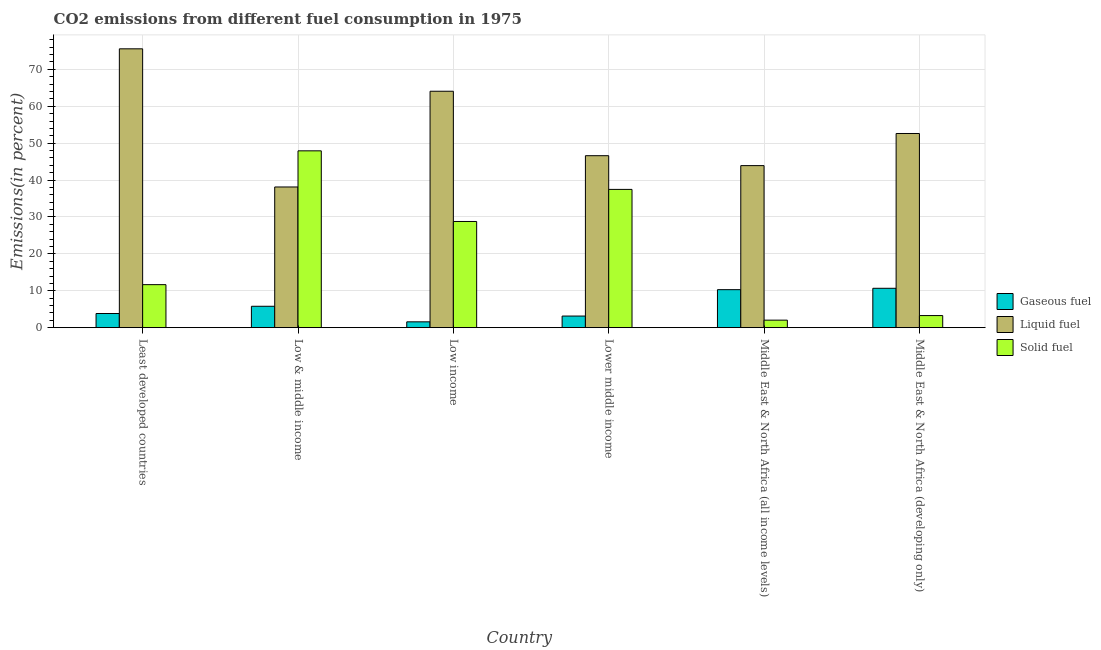How many different coloured bars are there?
Your answer should be compact. 3. Are the number of bars per tick equal to the number of legend labels?
Offer a very short reply. Yes. Are the number of bars on each tick of the X-axis equal?
Your answer should be compact. Yes. How many bars are there on the 2nd tick from the right?
Offer a very short reply. 3. What is the label of the 1st group of bars from the left?
Provide a short and direct response. Least developed countries. What is the percentage of gaseous fuel emission in Middle East & North Africa (developing only)?
Give a very brief answer. 10.67. Across all countries, what is the maximum percentage of liquid fuel emission?
Offer a very short reply. 75.57. Across all countries, what is the minimum percentage of gaseous fuel emission?
Provide a succinct answer. 1.58. In which country was the percentage of liquid fuel emission maximum?
Your answer should be very brief. Least developed countries. What is the total percentage of solid fuel emission in the graph?
Your answer should be compact. 131.15. What is the difference between the percentage of liquid fuel emission in Low income and that in Middle East & North Africa (developing only)?
Provide a succinct answer. 11.45. What is the difference between the percentage of liquid fuel emission in Low & middle income and the percentage of solid fuel emission in Least developed countries?
Keep it short and to the point. 26.47. What is the average percentage of liquid fuel emission per country?
Make the answer very short. 53.49. What is the difference between the percentage of solid fuel emission and percentage of gaseous fuel emission in Middle East & North Africa (all income levels)?
Your response must be concise. -8.26. What is the ratio of the percentage of gaseous fuel emission in Least developed countries to that in Lower middle income?
Your answer should be very brief. 1.22. What is the difference between the highest and the second highest percentage of gaseous fuel emission?
Offer a terse response. 0.37. What is the difference between the highest and the lowest percentage of solid fuel emission?
Keep it short and to the point. 45.89. Is the sum of the percentage of gaseous fuel emission in Low income and Middle East & North Africa (all income levels) greater than the maximum percentage of solid fuel emission across all countries?
Your answer should be very brief. No. What does the 2nd bar from the left in Low & middle income represents?
Ensure brevity in your answer.  Liquid fuel. What does the 3rd bar from the right in Low income represents?
Make the answer very short. Gaseous fuel. Is it the case that in every country, the sum of the percentage of gaseous fuel emission and percentage of liquid fuel emission is greater than the percentage of solid fuel emission?
Offer a terse response. No. Are all the bars in the graph horizontal?
Provide a succinct answer. No. How many countries are there in the graph?
Provide a succinct answer. 6. Are the values on the major ticks of Y-axis written in scientific E-notation?
Make the answer very short. No. Does the graph contain any zero values?
Your answer should be compact. No. Does the graph contain grids?
Give a very brief answer. Yes. How many legend labels are there?
Give a very brief answer. 3. How are the legend labels stacked?
Offer a very short reply. Vertical. What is the title of the graph?
Offer a terse response. CO2 emissions from different fuel consumption in 1975. Does "Slovak Republic" appear as one of the legend labels in the graph?
Make the answer very short. No. What is the label or title of the Y-axis?
Your answer should be compact. Emissions(in percent). What is the Emissions(in percent) in Gaseous fuel in Least developed countries?
Provide a short and direct response. 3.84. What is the Emissions(in percent) in Liquid fuel in Least developed countries?
Give a very brief answer. 75.57. What is the Emissions(in percent) of Solid fuel in Least developed countries?
Offer a terse response. 11.66. What is the Emissions(in percent) in Gaseous fuel in Low & middle income?
Provide a short and direct response. 5.8. What is the Emissions(in percent) of Liquid fuel in Low & middle income?
Give a very brief answer. 38.13. What is the Emissions(in percent) in Solid fuel in Low & middle income?
Give a very brief answer. 47.92. What is the Emissions(in percent) in Gaseous fuel in Low income?
Offer a terse response. 1.58. What is the Emissions(in percent) in Liquid fuel in Low income?
Your response must be concise. 64.07. What is the Emissions(in percent) of Solid fuel in Low income?
Offer a very short reply. 28.78. What is the Emissions(in percent) of Gaseous fuel in Lower middle income?
Give a very brief answer. 3.15. What is the Emissions(in percent) in Liquid fuel in Lower middle income?
Offer a very short reply. 46.61. What is the Emissions(in percent) in Solid fuel in Lower middle income?
Provide a short and direct response. 37.47. What is the Emissions(in percent) in Gaseous fuel in Middle East & North Africa (all income levels)?
Offer a terse response. 10.3. What is the Emissions(in percent) of Liquid fuel in Middle East & North Africa (all income levels)?
Your response must be concise. 43.92. What is the Emissions(in percent) of Solid fuel in Middle East & North Africa (all income levels)?
Give a very brief answer. 2.04. What is the Emissions(in percent) of Gaseous fuel in Middle East & North Africa (developing only)?
Your answer should be very brief. 10.67. What is the Emissions(in percent) in Liquid fuel in Middle East & North Africa (developing only)?
Make the answer very short. 52.63. What is the Emissions(in percent) of Solid fuel in Middle East & North Africa (developing only)?
Your answer should be very brief. 3.28. Across all countries, what is the maximum Emissions(in percent) of Gaseous fuel?
Make the answer very short. 10.67. Across all countries, what is the maximum Emissions(in percent) of Liquid fuel?
Ensure brevity in your answer.  75.57. Across all countries, what is the maximum Emissions(in percent) of Solid fuel?
Make the answer very short. 47.92. Across all countries, what is the minimum Emissions(in percent) of Gaseous fuel?
Keep it short and to the point. 1.58. Across all countries, what is the minimum Emissions(in percent) of Liquid fuel?
Ensure brevity in your answer.  38.13. Across all countries, what is the minimum Emissions(in percent) in Solid fuel?
Your answer should be compact. 2.04. What is the total Emissions(in percent) in Gaseous fuel in the graph?
Offer a terse response. 35.33. What is the total Emissions(in percent) in Liquid fuel in the graph?
Provide a short and direct response. 320.93. What is the total Emissions(in percent) in Solid fuel in the graph?
Offer a very short reply. 131.15. What is the difference between the Emissions(in percent) in Gaseous fuel in Least developed countries and that in Low & middle income?
Offer a terse response. -1.96. What is the difference between the Emissions(in percent) of Liquid fuel in Least developed countries and that in Low & middle income?
Your response must be concise. 37.44. What is the difference between the Emissions(in percent) in Solid fuel in Least developed countries and that in Low & middle income?
Your response must be concise. -36.27. What is the difference between the Emissions(in percent) in Gaseous fuel in Least developed countries and that in Low income?
Provide a succinct answer. 2.26. What is the difference between the Emissions(in percent) of Liquid fuel in Least developed countries and that in Low income?
Offer a very short reply. 11.5. What is the difference between the Emissions(in percent) in Solid fuel in Least developed countries and that in Low income?
Your answer should be compact. -17.12. What is the difference between the Emissions(in percent) of Gaseous fuel in Least developed countries and that in Lower middle income?
Your response must be concise. 0.69. What is the difference between the Emissions(in percent) in Liquid fuel in Least developed countries and that in Lower middle income?
Provide a succinct answer. 28.97. What is the difference between the Emissions(in percent) in Solid fuel in Least developed countries and that in Lower middle income?
Offer a terse response. -25.82. What is the difference between the Emissions(in percent) in Gaseous fuel in Least developed countries and that in Middle East & North Africa (all income levels)?
Your response must be concise. -6.46. What is the difference between the Emissions(in percent) of Liquid fuel in Least developed countries and that in Middle East & North Africa (all income levels)?
Provide a succinct answer. 31.65. What is the difference between the Emissions(in percent) in Solid fuel in Least developed countries and that in Middle East & North Africa (all income levels)?
Your answer should be very brief. 9.62. What is the difference between the Emissions(in percent) of Gaseous fuel in Least developed countries and that in Middle East & North Africa (developing only)?
Provide a short and direct response. -6.83. What is the difference between the Emissions(in percent) of Liquid fuel in Least developed countries and that in Middle East & North Africa (developing only)?
Offer a very short reply. 22.95. What is the difference between the Emissions(in percent) in Solid fuel in Least developed countries and that in Middle East & North Africa (developing only)?
Provide a succinct answer. 8.38. What is the difference between the Emissions(in percent) in Gaseous fuel in Low & middle income and that in Low income?
Your answer should be compact. 4.22. What is the difference between the Emissions(in percent) in Liquid fuel in Low & middle income and that in Low income?
Offer a terse response. -25.94. What is the difference between the Emissions(in percent) in Solid fuel in Low & middle income and that in Low income?
Offer a terse response. 19.14. What is the difference between the Emissions(in percent) in Gaseous fuel in Low & middle income and that in Lower middle income?
Your answer should be compact. 2.65. What is the difference between the Emissions(in percent) of Liquid fuel in Low & middle income and that in Lower middle income?
Ensure brevity in your answer.  -8.48. What is the difference between the Emissions(in percent) of Solid fuel in Low & middle income and that in Lower middle income?
Your response must be concise. 10.45. What is the difference between the Emissions(in percent) of Gaseous fuel in Low & middle income and that in Middle East & North Africa (all income levels)?
Your answer should be compact. -4.5. What is the difference between the Emissions(in percent) in Liquid fuel in Low & middle income and that in Middle East & North Africa (all income levels)?
Ensure brevity in your answer.  -5.79. What is the difference between the Emissions(in percent) of Solid fuel in Low & middle income and that in Middle East & North Africa (all income levels)?
Offer a terse response. 45.89. What is the difference between the Emissions(in percent) in Gaseous fuel in Low & middle income and that in Middle East & North Africa (developing only)?
Give a very brief answer. -4.88. What is the difference between the Emissions(in percent) of Liquid fuel in Low & middle income and that in Middle East & North Africa (developing only)?
Your answer should be very brief. -14.5. What is the difference between the Emissions(in percent) in Solid fuel in Low & middle income and that in Middle East & North Africa (developing only)?
Your answer should be compact. 44.65. What is the difference between the Emissions(in percent) in Gaseous fuel in Low income and that in Lower middle income?
Make the answer very short. -1.57. What is the difference between the Emissions(in percent) of Liquid fuel in Low income and that in Lower middle income?
Offer a terse response. 17.47. What is the difference between the Emissions(in percent) of Solid fuel in Low income and that in Lower middle income?
Make the answer very short. -8.69. What is the difference between the Emissions(in percent) in Gaseous fuel in Low income and that in Middle East & North Africa (all income levels)?
Ensure brevity in your answer.  -8.72. What is the difference between the Emissions(in percent) of Liquid fuel in Low income and that in Middle East & North Africa (all income levels)?
Keep it short and to the point. 20.16. What is the difference between the Emissions(in percent) of Solid fuel in Low income and that in Middle East & North Africa (all income levels)?
Offer a terse response. 26.74. What is the difference between the Emissions(in percent) in Gaseous fuel in Low income and that in Middle East & North Africa (developing only)?
Provide a short and direct response. -9.09. What is the difference between the Emissions(in percent) of Liquid fuel in Low income and that in Middle East & North Africa (developing only)?
Provide a succinct answer. 11.45. What is the difference between the Emissions(in percent) in Solid fuel in Low income and that in Middle East & North Africa (developing only)?
Keep it short and to the point. 25.5. What is the difference between the Emissions(in percent) of Gaseous fuel in Lower middle income and that in Middle East & North Africa (all income levels)?
Offer a very short reply. -7.15. What is the difference between the Emissions(in percent) of Liquid fuel in Lower middle income and that in Middle East & North Africa (all income levels)?
Give a very brief answer. 2.69. What is the difference between the Emissions(in percent) in Solid fuel in Lower middle income and that in Middle East & North Africa (all income levels)?
Offer a terse response. 35.44. What is the difference between the Emissions(in percent) of Gaseous fuel in Lower middle income and that in Middle East & North Africa (developing only)?
Give a very brief answer. -7.53. What is the difference between the Emissions(in percent) of Liquid fuel in Lower middle income and that in Middle East & North Africa (developing only)?
Give a very brief answer. -6.02. What is the difference between the Emissions(in percent) of Solid fuel in Lower middle income and that in Middle East & North Africa (developing only)?
Ensure brevity in your answer.  34.2. What is the difference between the Emissions(in percent) of Gaseous fuel in Middle East & North Africa (all income levels) and that in Middle East & North Africa (developing only)?
Offer a terse response. -0.37. What is the difference between the Emissions(in percent) in Liquid fuel in Middle East & North Africa (all income levels) and that in Middle East & North Africa (developing only)?
Provide a short and direct response. -8.71. What is the difference between the Emissions(in percent) of Solid fuel in Middle East & North Africa (all income levels) and that in Middle East & North Africa (developing only)?
Offer a terse response. -1.24. What is the difference between the Emissions(in percent) in Gaseous fuel in Least developed countries and the Emissions(in percent) in Liquid fuel in Low & middle income?
Ensure brevity in your answer.  -34.29. What is the difference between the Emissions(in percent) in Gaseous fuel in Least developed countries and the Emissions(in percent) in Solid fuel in Low & middle income?
Make the answer very short. -44.09. What is the difference between the Emissions(in percent) in Liquid fuel in Least developed countries and the Emissions(in percent) in Solid fuel in Low & middle income?
Provide a short and direct response. 27.65. What is the difference between the Emissions(in percent) of Gaseous fuel in Least developed countries and the Emissions(in percent) of Liquid fuel in Low income?
Ensure brevity in your answer.  -60.24. What is the difference between the Emissions(in percent) of Gaseous fuel in Least developed countries and the Emissions(in percent) of Solid fuel in Low income?
Give a very brief answer. -24.94. What is the difference between the Emissions(in percent) in Liquid fuel in Least developed countries and the Emissions(in percent) in Solid fuel in Low income?
Offer a very short reply. 46.79. What is the difference between the Emissions(in percent) of Gaseous fuel in Least developed countries and the Emissions(in percent) of Liquid fuel in Lower middle income?
Provide a short and direct response. -42.77. What is the difference between the Emissions(in percent) of Gaseous fuel in Least developed countries and the Emissions(in percent) of Solid fuel in Lower middle income?
Provide a succinct answer. -33.64. What is the difference between the Emissions(in percent) of Liquid fuel in Least developed countries and the Emissions(in percent) of Solid fuel in Lower middle income?
Your answer should be compact. 38.1. What is the difference between the Emissions(in percent) of Gaseous fuel in Least developed countries and the Emissions(in percent) of Liquid fuel in Middle East & North Africa (all income levels)?
Ensure brevity in your answer.  -40.08. What is the difference between the Emissions(in percent) in Gaseous fuel in Least developed countries and the Emissions(in percent) in Solid fuel in Middle East & North Africa (all income levels)?
Your response must be concise. 1.8. What is the difference between the Emissions(in percent) in Liquid fuel in Least developed countries and the Emissions(in percent) in Solid fuel in Middle East & North Africa (all income levels)?
Your answer should be very brief. 73.54. What is the difference between the Emissions(in percent) of Gaseous fuel in Least developed countries and the Emissions(in percent) of Liquid fuel in Middle East & North Africa (developing only)?
Ensure brevity in your answer.  -48.79. What is the difference between the Emissions(in percent) of Gaseous fuel in Least developed countries and the Emissions(in percent) of Solid fuel in Middle East & North Africa (developing only)?
Offer a very short reply. 0.56. What is the difference between the Emissions(in percent) of Liquid fuel in Least developed countries and the Emissions(in percent) of Solid fuel in Middle East & North Africa (developing only)?
Ensure brevity in your answer.  72.3. What is the difference between the Emissions(in percent) in Gaseous fuel in Low & middle income and the Emissions(in percent) in Liquid fuel in Low income?
Keep it short and to the point. -58.28. What is the difference between the Emissions(in percent) of Gaseous fuel in Low & middle income and the Emissions(in percent) of Solid fuel in Low income?
Your answer should be compact. -22.98. What is the difference between the Emissions(in percent) in Liquid fuel in Low & middle income and the Emissions(in percent) in Solid fuel in Low income?
Provide a short and direct response. 9.35. What is the difference between the Emissions(in percent) of Gaseous fuel in Low & middle income and the Emissions(in percent) of Liquid fuel in Lower middle income?
Ensure brevity in your answer.  -40.81. What is the difference between the Emissions(in percent) of Gaseous fuel in Low & middle income and the Emissions(in percent) of Solid fuel in Lower middle income?
Provide a short and direct response. -31.68. What is the difference between the Emissions(in percent) in Liquid fuel in Low & middle income and the Emissions(in percent) in Solid fuel in Lower middle income?
Make the answer very short. 0.66. What is the difference between the Emissions(in percent) in Gaseous fuel in Low & middle income and the Emissions(in percent) in Liquid fuel in Middle East & North Africa (all income levels)?
Provide a succinct answer. -38.12. What is the difference between the Emissions(in percent) in Gaseous fuel in Low & middle income and the Emissions(in percent) in Solid fuel in Middle East & North Africa (all income levels)?
Your answer should be compact. 3.76. What is the difference between the Emissions(in percent) of Liquid fuel in Low & middle income and the Emissions(in percent) of Solid fuel in Middle East & North Africa (all income levels)?
Keep it short and to the point. 36.09. What is the difference between the Emissions(in percent) of Gaseous fuel in Low & middle income and the Emissions(in percent) of Liquid fuel in Middle East & North Africa (developing only)?
Your response must be concise. -46.83. What is the difference between the Emissions(in percent) in Gaseous fuel in Low & middle income and the Emissions(in percent) in Solid fuel in Middle East & North Africa (developing only)?
Offer a terse response. 2.52. What is the difference between the Emissions(in percent) in Liquid fuel in Low & middle income and the Emissions(in percent) in Solid fuel in Middle East & North Africa (developing only)?
Ensure brevity in your answer.  34.85. What is the difference between the Emissions(in percent) in Gaseous fuel in Low income and the Emissions(in percent) in Liquid fuel in Lower middle income?
Give a very brief answer. -45.03. What is the difference between the Emissions(in percent) in Gaseous fuel in Low income and the Emissions(in percent) in Solid fuel in Lower middle income?
Make the answer very short. -35.89. What is the difference between the Emissions(in percent) of Liquid fuel in Low income and the Emissions(in percent) of Solid fuel in Lower middle income?
Offer a terse response. 26.6. What is the difference between the Emissions(in percent) of Gaseous fuel in Low income and the Emissions(in percent) of Liquid fuel in Middle East & North Africa (all income levels)?
Provide a succinct answer. -42.34. What is the difference between the Emissions(in percent) of Gaseous fuel in Low income and the Emissions(in percent) of Solid fuel in Middle East & North Africa (all income levels)?
Ensure brevity in your answer.  -0.46. What is the difference between the Emissions(in percent) of Liquid fuel in Low income and the Emissions(in percent) of Solid fuel in Middle East & North Africa (all income levels)?
Give a very brief answer. 62.04. What is the difference between the Emissions(in percent) in Gaseous fuel in Low income and the Emissions(in percent) in Liquid fuel in Middle East & North Africa (developing only)?
Make the answer very short. -51.05. What is the difference between the Emissions(in percent) in Gaseous fuel in Low income and the Emissions(in percent) in Solid fuel in Middle East & North Africa (developing only)?
Offer a very short reply. -1.7. What is the difference between the Emissions(in percent) in Liquid fuel in Low income and the Emissions(in percent) in Solid fuel in Middle East & North Africa (developing only)?
Your answer should be very brief. 60.8. What is the difference between the Emissions(in percent) in Gaseous fuel in Lower middle income and the Emissions(in percent) in Liquid fuel in Middle East & North Africa (all income levels)?
Make the answer very short. -40.77. What is the difference between the Emissions(in percent) in Gaseous fuel in Lower middle income and the Emissions(in percent) in Solid fuel in Middle East & North Africa (all income levels)?
Provide a succinct answer. 1.11. What is the difference between the Emissions(in percent) in Liquid fuel in Lower middle income and the Emissions(in percent) in Solid fuel in Middle East & North Africa (all income levels)?
Provide a succinct answer. 44.57. What is the difference between the Emissions(in percent) of Gaseous fuel in Lower middle income and the Emissions(in percent) of Liquid fuel in Middle East & North Africa (developing only)?
Ensure brevity in your answer.  -49.48. What is the difference between the Emissions(in percent) of Gaseous fuel in Lower middle income and the Emissions(in percent) of Solid fuel in Middle East & North Africa (developing only)?
Provide a short and direct response. -0.13. What is the difference between the Emissions(in percent) of Liquid fuel in Lower middle income and the Emissions(in percent) of Solid fuel in Middle East & North Africa (developing only)?
Ensure brevity in your answer.  43.33. What is the difference between the Emissions(in percent) of Gaseous fuel in Middle East & North Africa (all income levels) and the Emissions(in percent) of Liquid fuel in Middle East & North Africa (developing only)?
Provide a short and direct response. -42.33. What is the difference between the Emissions(in percent) in Gaseous fuel in Middle East & North Africa (all income levels) and the Emissions(in percent) in Solid fuel in Middle East & North Africa (developing only)?
Offer a very short reply. 7.02. What is the difference between the Emissions(in percent) in Liquid fuel in Middle East & North Africa (all income levels) and the Emissions(in percent) in Solid fuel in Middle East & North Africa (developing only)?
Provide a short and direct response. 40.64. What is the average Emissions(in percent) of Gaseous fuel per country?
Ensure brevity in your answer.  5.89. What is the average Emissions(in percent) in Liquid fuel per country?
Provide a short and direct response. 53.49. What is the average Emissions(in percent) in Solid fuel per country?
Make the answer very short. 21.86. What is the difference between the Emissions(in percent) in Gaseous fuel and Emissions(in percent) in Liquid fuel in Least developed countries?
Provide a succinct answer. -71.74. What is the difference between the Emissions(in percent) in Gaseous fuel and Emissions(in percent) in Solid fuel in Least developed countries?
Offer a terse response. -7.82. What is the difference between the Emissions(in percent) in Liquid fuel and Emissions(in percent) in Solid fuel in Least developed countries?
Offer a very short reply. 63.92. What is the difference between the Emissions(in percent) in Gaseous fuel and Emissions(in percent) in Liquid fuel in Low & middle income?
Offer a terse response. -32.33. What is the difference between the Emissions(in percent) in Gaseous fuel and Emissions(in percent) in Solid fuel in Low & middle income?
Your answer should be compact. -42.13. What is the difference between the Emissions(in percent) of Liquid fuel and Emissions(in percent) of Solid fuel in Low & middle income?
Provide a succinct answer. -9.8. What is the difference between the Emissions(in percent) of Gaseous fuel and Emissions(in percent) of Liquid fuel in Low income?
Offer a very short reply. -62.49. What is the difference between the Emissions(in percent) in Gaseous fuel and Emissions(in percent) in Solid fuel in Low income?
Provide a succinct answer. -27.2. What is the difference between the Emissions(in percent) of Liquid fuel and Emissions(in percent) of Solid fuel in Low income?
Give a very brief answer. 35.29. What is the difference between the Emissions(in percent) of Gaseous fuel and Emissions(in percent) of Liquid fuel in Lower middle income?
Offer a terse response. -43.46. What is the difference between the Emissions(in percent) of Gaseous fuel and Emissions(in percent) of Solid fuel in Lower middle income?
Your answer should be very brief. -34.33. What is the difference between the Emissions(in percent) of Liquid fuel and Emissions(in percent) of Solid fuel in Lower middle income?
Ensure brevity in your answer.  9.13. What is the difference between the Emissions(in percent) in Gaseous fuel and Emissions(in percent) in Liquid fuel in Middle East & North Africa (all income levels)?
Provide a short and direct response. -33.62. What is the difference between the Emissions(in percent) of Gaseous fuel and Emissions(in percent) of Solid fuel in Middle East & North Africa (all income levels)?
Provide a short and direct response. 8.26. What is the difference between the Emissions(in percent) of Liquid fuel and Emissions(in percent) of Solid fuel in Middle East & North Africa (all income levels)?
Give a very brief answer. 41.88. What is the difference between the Emissions(in percent) in Gaseous fuel and Emissions(in percent) in Liquid fuel in Middle East & North Africa (developing only)?
Your answer should be compact. -41.95. What is the difference between the Emissions(in percent) of Gaseous fuel and Emissions(in percent) of Solid fuel in Middle East & North Africa (developing only)?
Your response must be concise. 7.4. What is the difference between the Emissions(in percent) in Liquid fuel and Emissions(in percent) in Solid fuel in Middle East & North Africa (developing only)?
Offer a very short reply. 49.35. What is the ratio of the Emissions(in percent) in Gaseous fuel in Least developed countries to that in Low & middle income?
Provide a succinct answer. 0.66. What is the ratio of the Emissions(in percent) of Liquid fuel in Least developed countries to that in Low & middle income?
Your response must be concise. 1.98. What is the ratio of the Emissions(in percent) of Solid fuel in Least developed countries to that in Low & middle income?
Make the answer very short. 0.24. What is the ratio of the Emissions(in percent) of Gaseous fuel in Least developed countries to that in Low income?
Your answer should be very brief. 2.43. What is the ratio of the Emissions(in percent) of Liquid fuel in Least developed countries to that in Low income?
Ensure brevity in your answer.  1.18. What is the ratio of the Emissions(in percent) of Solid fuel in Least developed countries to that in Low income?
Your answer should be very brief. 0.41. What is the ratio of the Emissions(in percent) of Gaseous fuel in Least developed countries to that in Lower middle income?
Keep it short and to the point. 1.22. What is the ratio of the Emissions(in percent) of Liquid fuel in Least developed countries to that in Lower middle income?
Ensure brevity in your answer.  1.62. What is the ratio of the Emissions(in percent) in Solid fuel in Least developed countries to that in Lower middle income?
Give a very brief answer. 0.31. What is the ratio of the Emissions(in percent) of Gaseous fuel in Least developed countries to that in Middle East & North Africa (all income levels)?
Your answer should be compact. 0.37. What is the ratio of the Emissions(in percent) of Liquid fuel in Least developed countries to that in Middle East & North Africa (all income levels)?
Your response must be concise. 1.72. What is the ratio of the Emissions(in percent) in Solid fuel in Least developed countries to that in Middle East & North Africa (all income levels)?
Offer a very short reply. 5.73. What is the ratio of the Emissions(in percent) of Gaseous fuel in Least developed countries to that in Middle East & North Africa (developing only)?
Offer a terse response. 0.36. What is the ratio of the Emissions(in percent) in Liquid fuel in Least developed countries to that in Middle East & North Africa (developing only)?
Give a very brief answer. 1.44. What is the ratio of the Emissions(in percent) of Solid fuel in Least developed countries to that in Middle East & North Africa (developing only)?
Offer a very short reply. 3.56. What is the ratio of the Emissions(in percent) of Gaseous fuel in Low & middle income to that in Low income?
Provide a succinct answer. 3.67. What is the ratio of the Emissions(in percent) in Liquid fuel in Low & middle income to that in Low income?
Give a very brief answer. 0.6. What is the ratio of the Emissions(in percent) in Solid fuel in Low & middle income to that in Low income?
Your response must be concise. 1.67. What is the ratio of the Emissions(in percent) in Gaseous fuel in Low & middle income to that in Lower middle income?
Provide a succinct answer. 1.84. What is the ratio of the Emissions(in percent) of Liquid fuel in Low & middle income to that in Lower middle income?
Your answer should be very brief. 0.82. What is the ratio of the Emissions(in percent) in Solid fuel in Low & middle income to that in Lower middle income?
Make the answer very short. 1.28. What is the ratio of the Emissions(in percent) of Gaseous fuel in Low & middle income to that in Middle East & North Africa (all income levels)?
Your answer should be compact. 0.56. What is the ratio of the Emissions(in percent) in Liquid fuel in Low & middle income to that in Middle East & North Africa (all income levels)?
Your answer should be very brief. 0.87. What is the ratio of the Emissions(in percent) in Solid fuel in Low & middle income to that in Middle East & North Africa (all income levels)?
Give a very brief answer. 23.55. What is the ratio of the Emissions(in percent) in Gaseous fuel in Low & middle income to that in Middle East & North Africa (developing only)?
Your answer should be compact. 0.54. What is the ratio of the Emissions(in percent) in Liquid fuel in Low & middle income to that in Middle East & North Africa (developing only)?
Your response must be concise. 0.72. What is the ratio of the Emissions(in percent) in Solid fuel in Low & middle income to that in Middle East & North Africa (developing only)?
Offer a terse response. 14.63. What is the ratio of the Emissions(in percent) in Gaseous fuel in Low income to that in Lower middle income?
Offer a terse response. 0.5. What is the ratio of the Emissions(in percent) in Liquid fuel in Low income to that in Lower middle income?
Ensure brevity in your answer.  1.37. What is the ratio of the Emissions(in percent) in Solid fuel in Low income to that in Lower middle income?
Provide a short and direct response. 0.77. What is the ratio of the Emissions(in percent) in Gaseous fuel in Low income to that in Middle East & North Africa (all income levels)?
Keep it short and to the point. 0.15. What is the ratio of the Emissions(in percent) in Liquid fuel in Low income to that in Middle East & North Africa (all income levels)?
Provide a succinct answer. 1.46. What is the ratio of the Emissions(in percent) in Solid fuel in Low income to that in Middle East & North Africa (all income levels)?
Ensure brevity in your answer.  14.14. What is the ratio of the Emissions(in percent) of Gaseous fuel in Low income to that in Middle East & North Africa (developing only)?
Offer a very short reply. 0.15. What is the ratio of the Emissions(in percent) of Liquid fuel in Low income to that in Middle East & North Africa (developing only)?
Ensure brevity in your answer.  1.22. What is the ratio of the Emissions(in percent) in Solid fuel in Low income to that in Middle East & North Africa (developing only)?
Your answer should be compact. 8.78. What is the ratio of the Emissions(in percent) in Gaseous fuel in Lower middle income to that in Middle East & North Africa (all income levels)?
Keep it short and to the point. 0.31. What is the ratio of the Emissions(in percent) of Liquid fuel in Lower middle income to that in Middle East & North Africa (all income levels)?
Make the answer very short. 1.06. What is the ratio of the Emissions(in percent) of Solid fuel in Lower middle income to that in Middle East & North Africa (all income levels)?
Your answer should be very brief. 18.41. What is the ratio of the Emissions(in percent) of Gaseous fuel in Lower middle income to that in Middle East & North Africa (developing only)?
Offer a very short reply. 0.29. What is the ratio of the Emissions(in percent) in Liquid fuel in Lower middle income to that in Middle East & North Africa (developing only)?
Your response must be concise. 0.89. What is the ratio of the Emissions(in percent) in Solid fuel in Lower middle income to that in Middle East & North Africa (developing only)?
Offer a terse response. 11.44. What is the ratio of the Emissions(in percent) in Gaseous fuel in Middle East & North Africa (all income levels) to that in Middle East & North Africa (developing only)?
Provide a succinct answer. 0.97. What is the ratio of the Emissions(in percent) in Liquid fuel in Middle East & North Africa (all income levels) to that in Middle East & North Africa (developing only)?
Your answer should be compact. 0.83. What is the ratio of the Emissions(in percent) of Solid fuel in Middle East & North Africa (all income levels) to that in Middle East & North Africa (developing only)?
Your answer should be very brief. 0.62. What is the difference between the highest and the second highest Emissions(in percent) of Gaseous fuel?
Offer a terse response. 0.37. What is the difference between the highest and the second highest Emissions(in percent) in Liquid fuel?
Offer a terse response. 11.5. What is the difference between the highest and the second highest Emissions(in percent) in Solid fuel?
Keep it short and to the point. 10.45. What is the difference between the highest and the lowest Emissions(in percent) in Gaseous fuel?
Make the answer very short. 9.09. What is the difference between the highest and the lowest Emissions(in percent) of Liquid fuel?
Keep it short and to the point. 37.44. What is the difference between the highest and the lowest Emissions(in percent) in Solid fuel?
Provide a succinct answer. 45.89. 